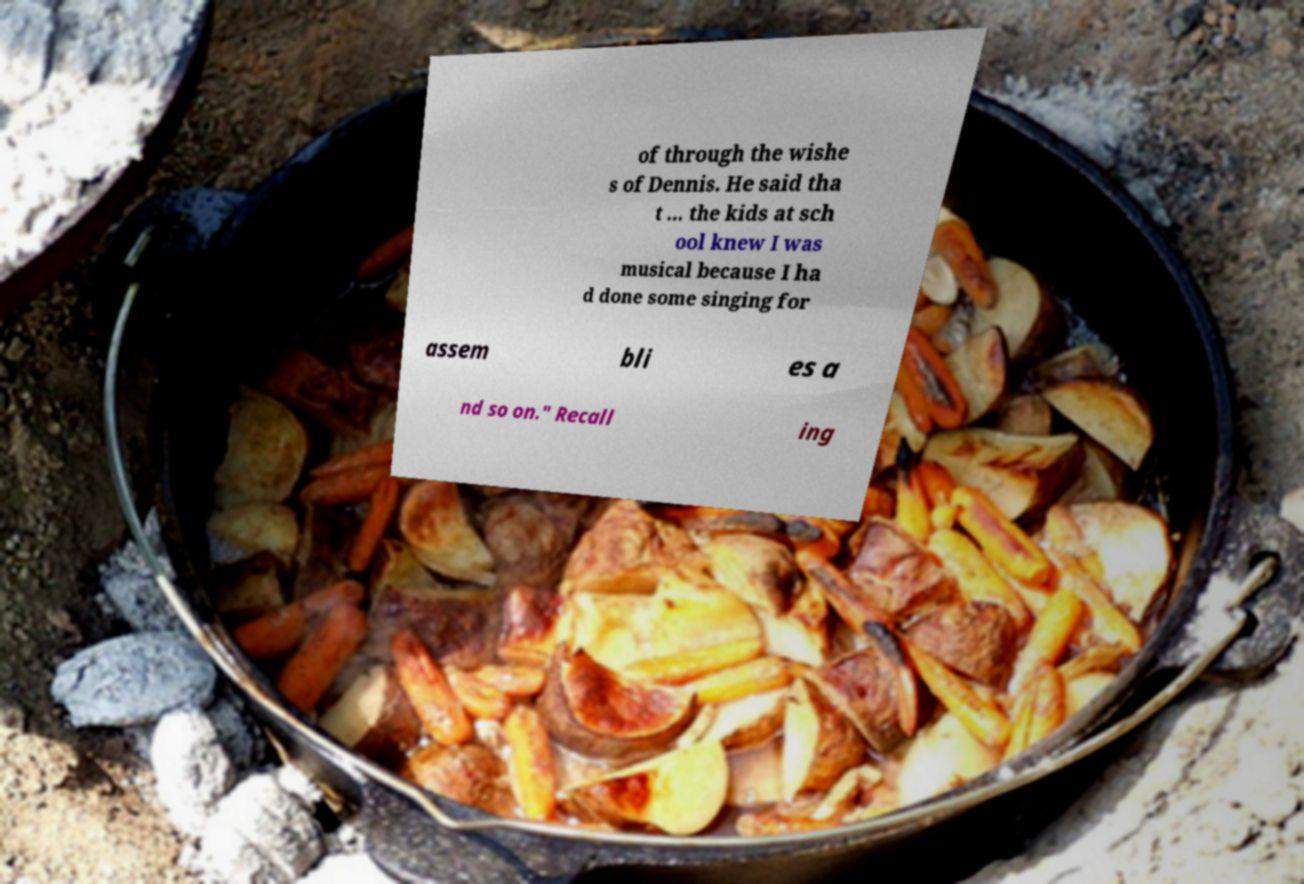Could you extract and type out the text from this image? of through the wishe s of Dennis. He said tha t ... the kids at sch ool knew I was musical because I ha d done some singing for assem bli es a nd so on." Recall ing 